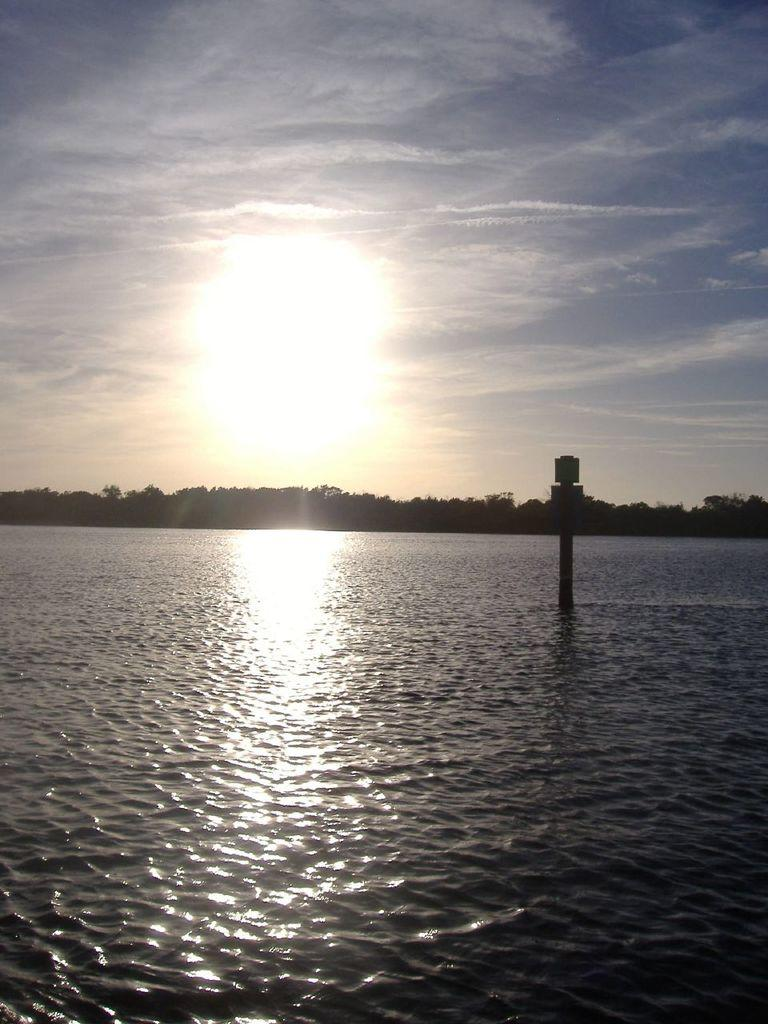What type of natural feature is present in the image? There is a lake in the image. What can be seen in the middle of the lake? There is a pole in the middle of the lake. What type of vegetation surrounds the lake? There are trees surrounding the lake. What is visible in the sky in the image? The sun is visible in the sky. What type of transport can be seen in the downtown area in the image? There is no downtown area or transport visible in the image; it features a lake with a pole and trees. 